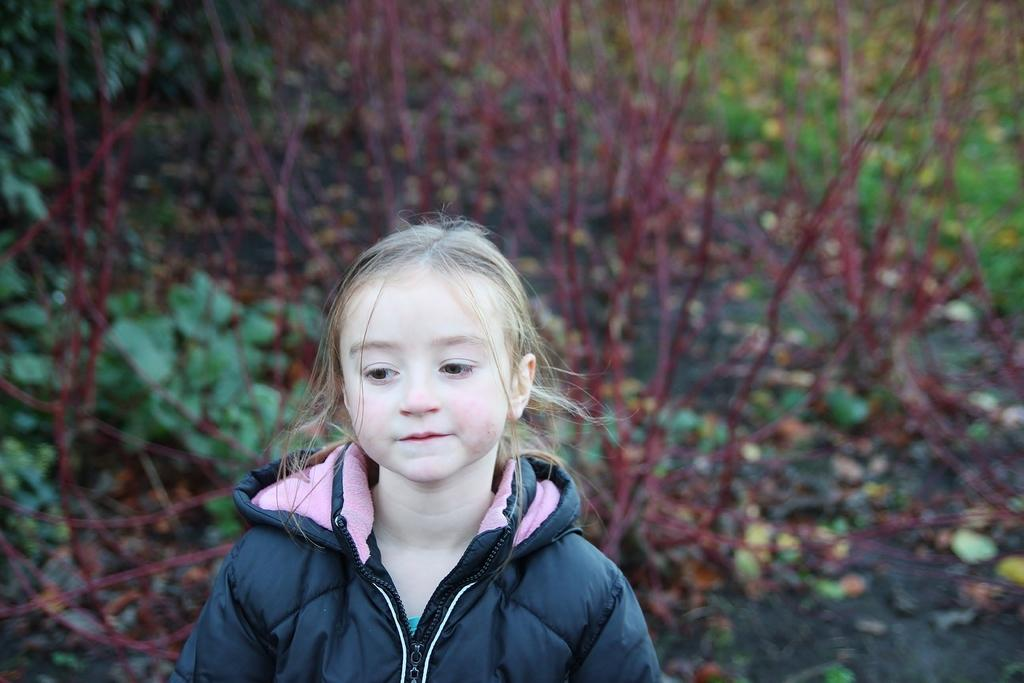What type of vegetation can be seen in the background of the image? There are green leaves in the background of the image. What else is present in the background of the image? There is a net in the background of the image. Who is the main subject of the image? The main subject of the image is a girl. What is the girl wearing in the image? The girl is wearing a jacket. What is the name of the person standing next to the girl in the image? There is no person standing next to the girl in the image. How far away is the girl from the net in the image? The distance between the girl and the net cannot be determined from the image. 